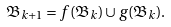<formula> <loc_0><loc_0><loc_500><loc_500>\mathfrak { B } _ { k + 1 } = f ( \mathfrak { B } _ { k } ) \cup g ( \mathfrak { B } _ { k } ) .</formula> 